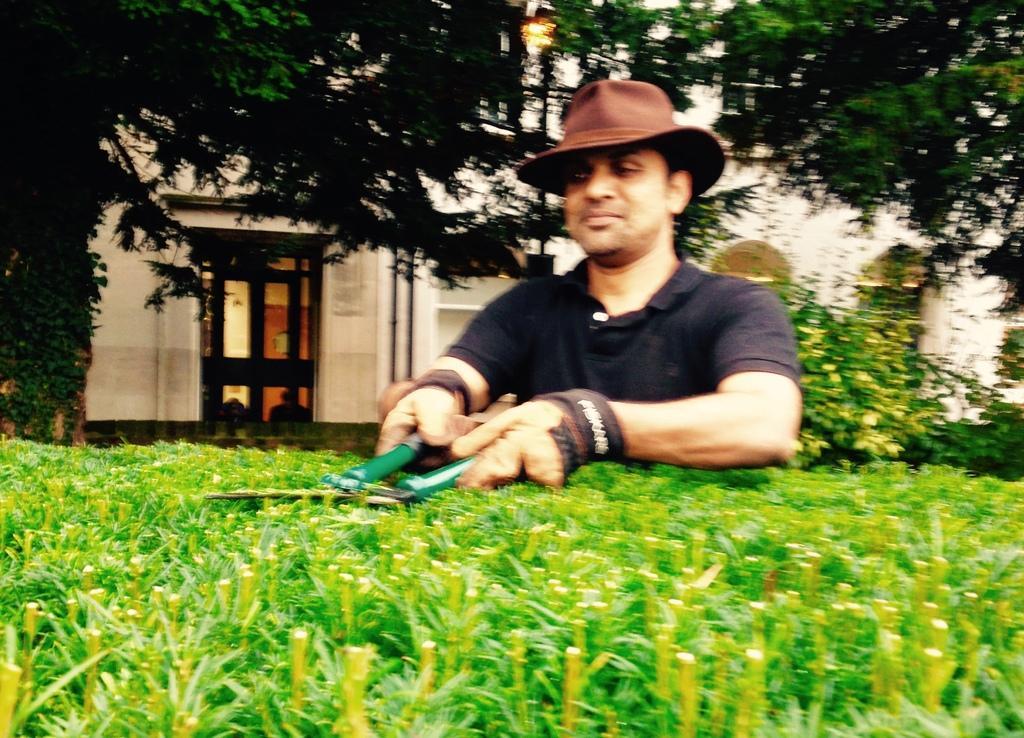Please provide a concise description of this image. In this image I can see the person holding the scissor and the person is wearing black color shirt and I can see few plants in green color. In the background I can see the building in cream color and I can also see the door. 